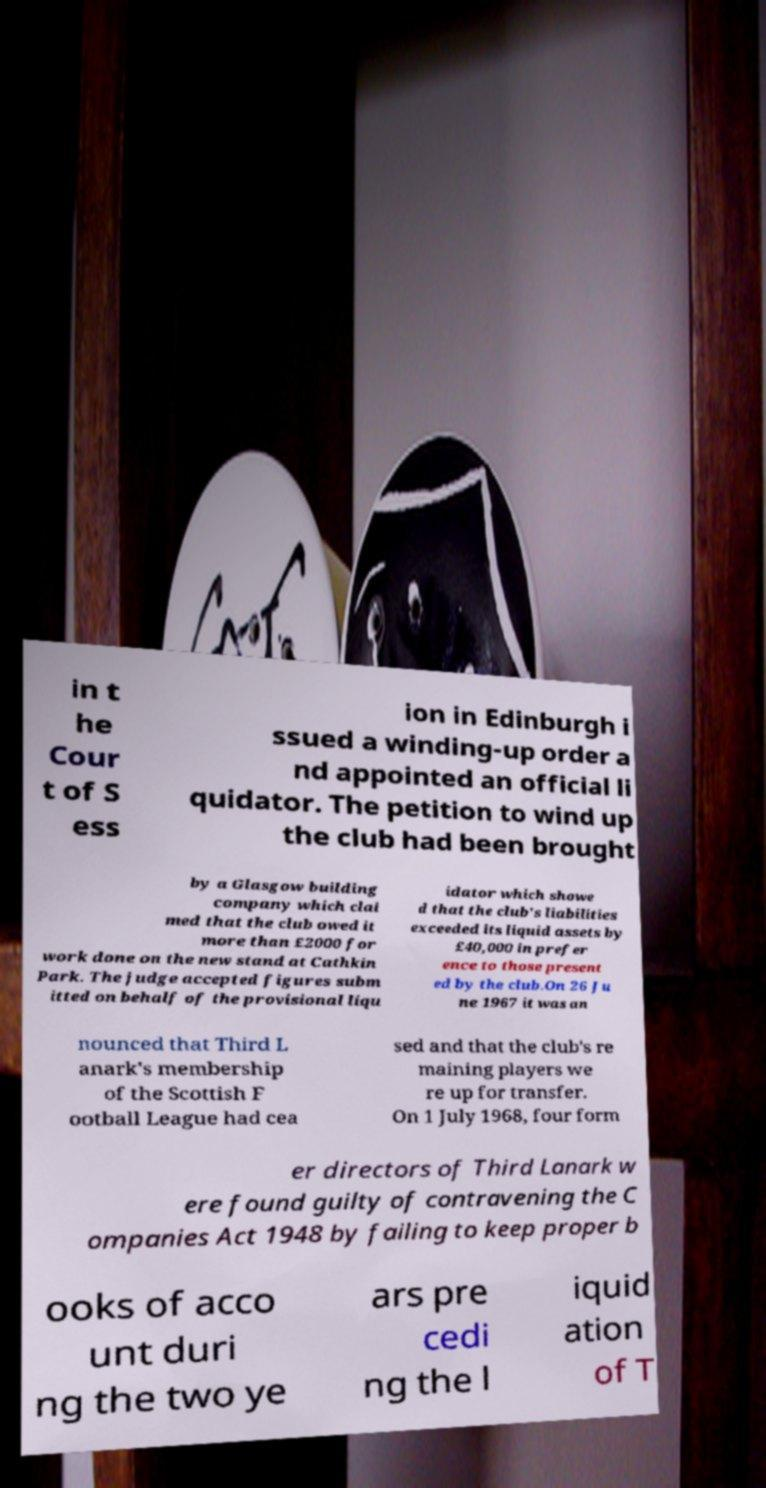Can you accurately transcribe the text from the provided image for me? in t he Cour t of S ess ion in Edinburgh i ssued a winding-up order a nd appointed an official li quidator. The petition to wind up the club had been brought by a Glasgow building company which clai med that the club owed it more than £2000 for work done on the new stand at Cathkin Park. The judge accepted figures subm itted on behalf of the provisional liqu idator which showe d that the club's liabilities exceeded its liquid assets by £40,000 in prefer ence to those present ed by the club.On 26 Ju ne 1967 it was an nounced that Third L anark's membership of the Scottish F ootball League had cea sed and that the club's re maining players we re up for transfer. On 1 July 1968, four form er directors of Third Lanark w ere found guilty of contravening the C ompanies Act 1948 by failing to keep proper b ooks of acco unt duri ng the two ye ars pre cedi ng the l iquid ation of T 